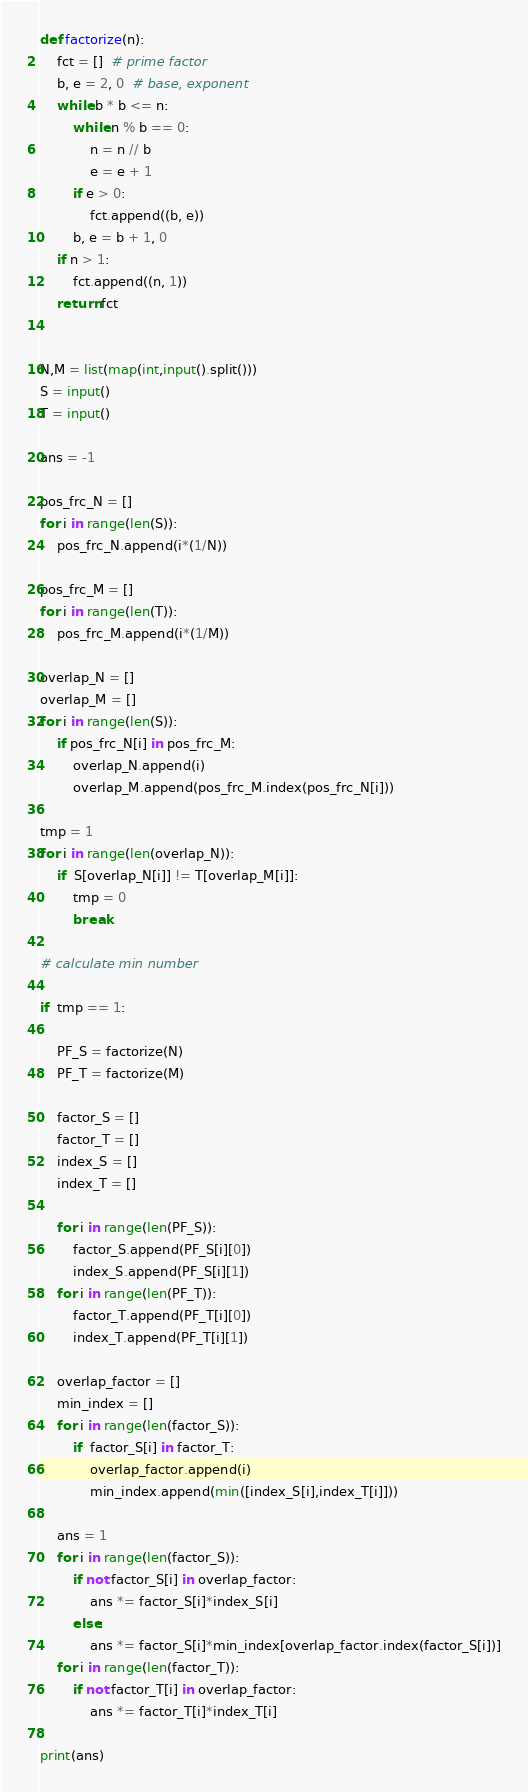Convert code to text. <code><loc_0><loc_0><loc_500><loc_500><_Python_>
def factorize(n):
    fct = []  # prime factor
    b, e = 2, 0  # base, exponent
    while b * b <= n:
        while n % b == 0:
            n = n // b
            e = e + 1
        if e > 0:
            fct.append((b, e))
        b, e = b + 1, 0
    if n > 1:
        fct.append((n, 1))
    return fct


N,M = list(map(int,input().split()))
S = input()
T = input()

ans = -1

pos_frc_N = []
for i in range(len(S)):
    pos_frc_N.append(i*(1/N))
    
pos_frc_M = []
for i in range(len(T)):
    pos_frc_M.append(i*(1/M))

overlap_N = []
overlap_M = []
for i in range(len(S)):
    if pos_frc_N[i] in pos_frc_M:
        overlap_N.append(i)
        overlap_M.append(pos_frc_M.index(pos_frc_N[i]))

tmp = 1
for i in range(len(overlap_N)):
    if  S[overlap_N[i]] != T[overlap_M[i]]:
        tmp = 0
        break

# calculate min number
    
if  tmp == 1:
    
    PF_S = factorize(N)
    PF_T = factorize(M)
    
    factor_S = []
    factor_T = []
    index_S = []
    index_T = []
    
    for i in range(len(PF_S)):
        factor_S.append(PF_S[i][0])
        index_S.append(PF_S[i][1])
    for i in range(len(PF_T)):
        factor_T.append(PF_T[i][0])
        index_T.append(PF_T[i][1])
        
    overlap_factor = []
    min_index = []
    for i in range(len(factor_S)):
        if  factor_S[i] in factor_T:
            overlap_factor.append(i)
            min_index.append(min([index_S[i],index_T[i]]))
    
    ans = 1
    for i in range(len(factor_S)):
        if not factor_S[i] in overlap_factor:
            ans *= factor_S[i]*index_S[i]
        else:
            ans *= factor_S[i]*min_index[overlap_factor.index(factor_S[i])]
    for i in range(len(factor_T)):
        if not factor_T[i] in overlap_factor:
            ans *= factor_T[i]*index_T[i]
            
print(ans)


</code> 